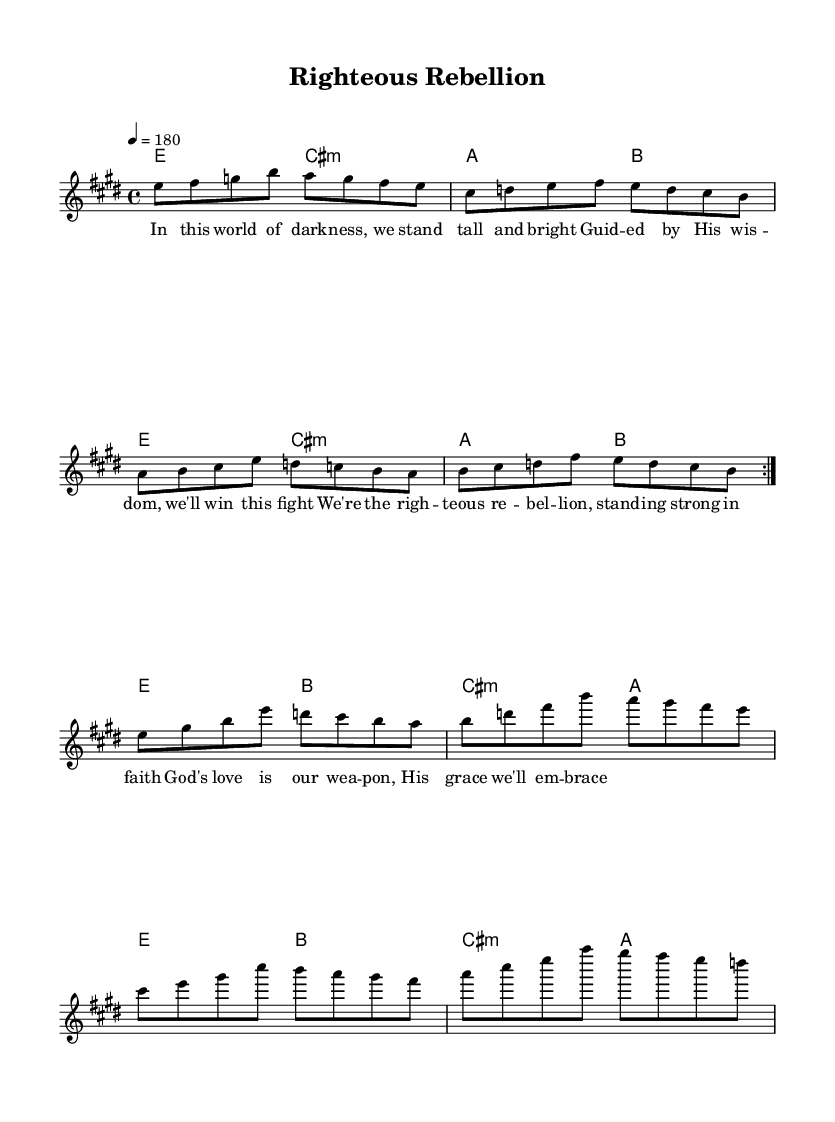What is the key signature of this music? The key signature indicates the presence of sharps or flats in the piece. The music shows a key signature with four sharps, which corresponds to E major.
Answer: E major What is the time signature of this music? The time signature is represented by the numbers at the beginning of the piece. It shows the number of beats in each measure, and in this case, it is 4/4, indicating four beats per measure.
Answer: 4/4 What is the tempo of this music? The tempo marking specifies how fast the music should be played, indicated by the number above the staff. Here, it is set to 180 beats per minute, which is a lively tempo.
Answer: 180 How many measures are in the first section of the melody? The first section of the melody is marked by a repeat sign and consists of two identical sections. Each section has four measures, totaling eight measures before any break.
Answer: 8 What does the title of the song suggest about its theme? The title "Righteous Rebellion" indicates a theme of standing up for one's beliefs and fighting against darkness, which is often a central message in Christian punk rock.
Answer: Christian punk messages What is the function of God's love in the lyrics? The lyrics refer to God's love as a weapon, a metaphor that suggests strength and protection against challenges, reflecting a positive message in Christian punk rock.
Answer: A weapon How does the chord progression support the melody? The chord progression follows the melody closely, providing harmonic support that enhances the song's uplifting message, which is characteristic of the punk genre's energy.
Answer: Enhances the message 